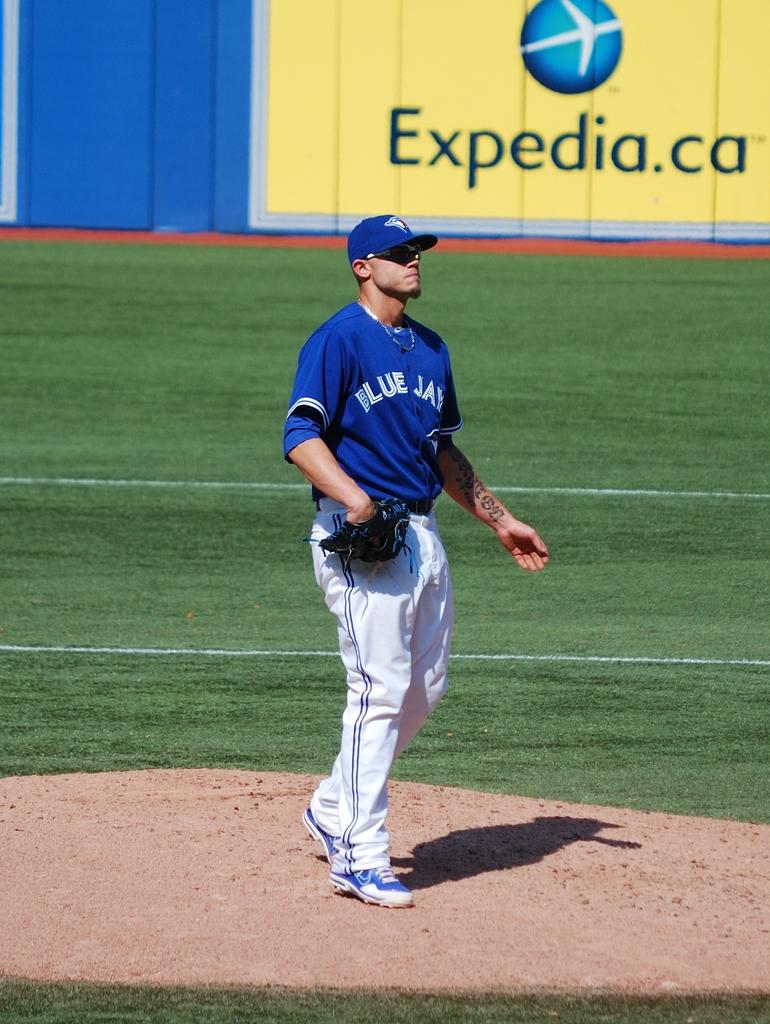Who is the sponsor?
Make the answer very short. Expedia. 